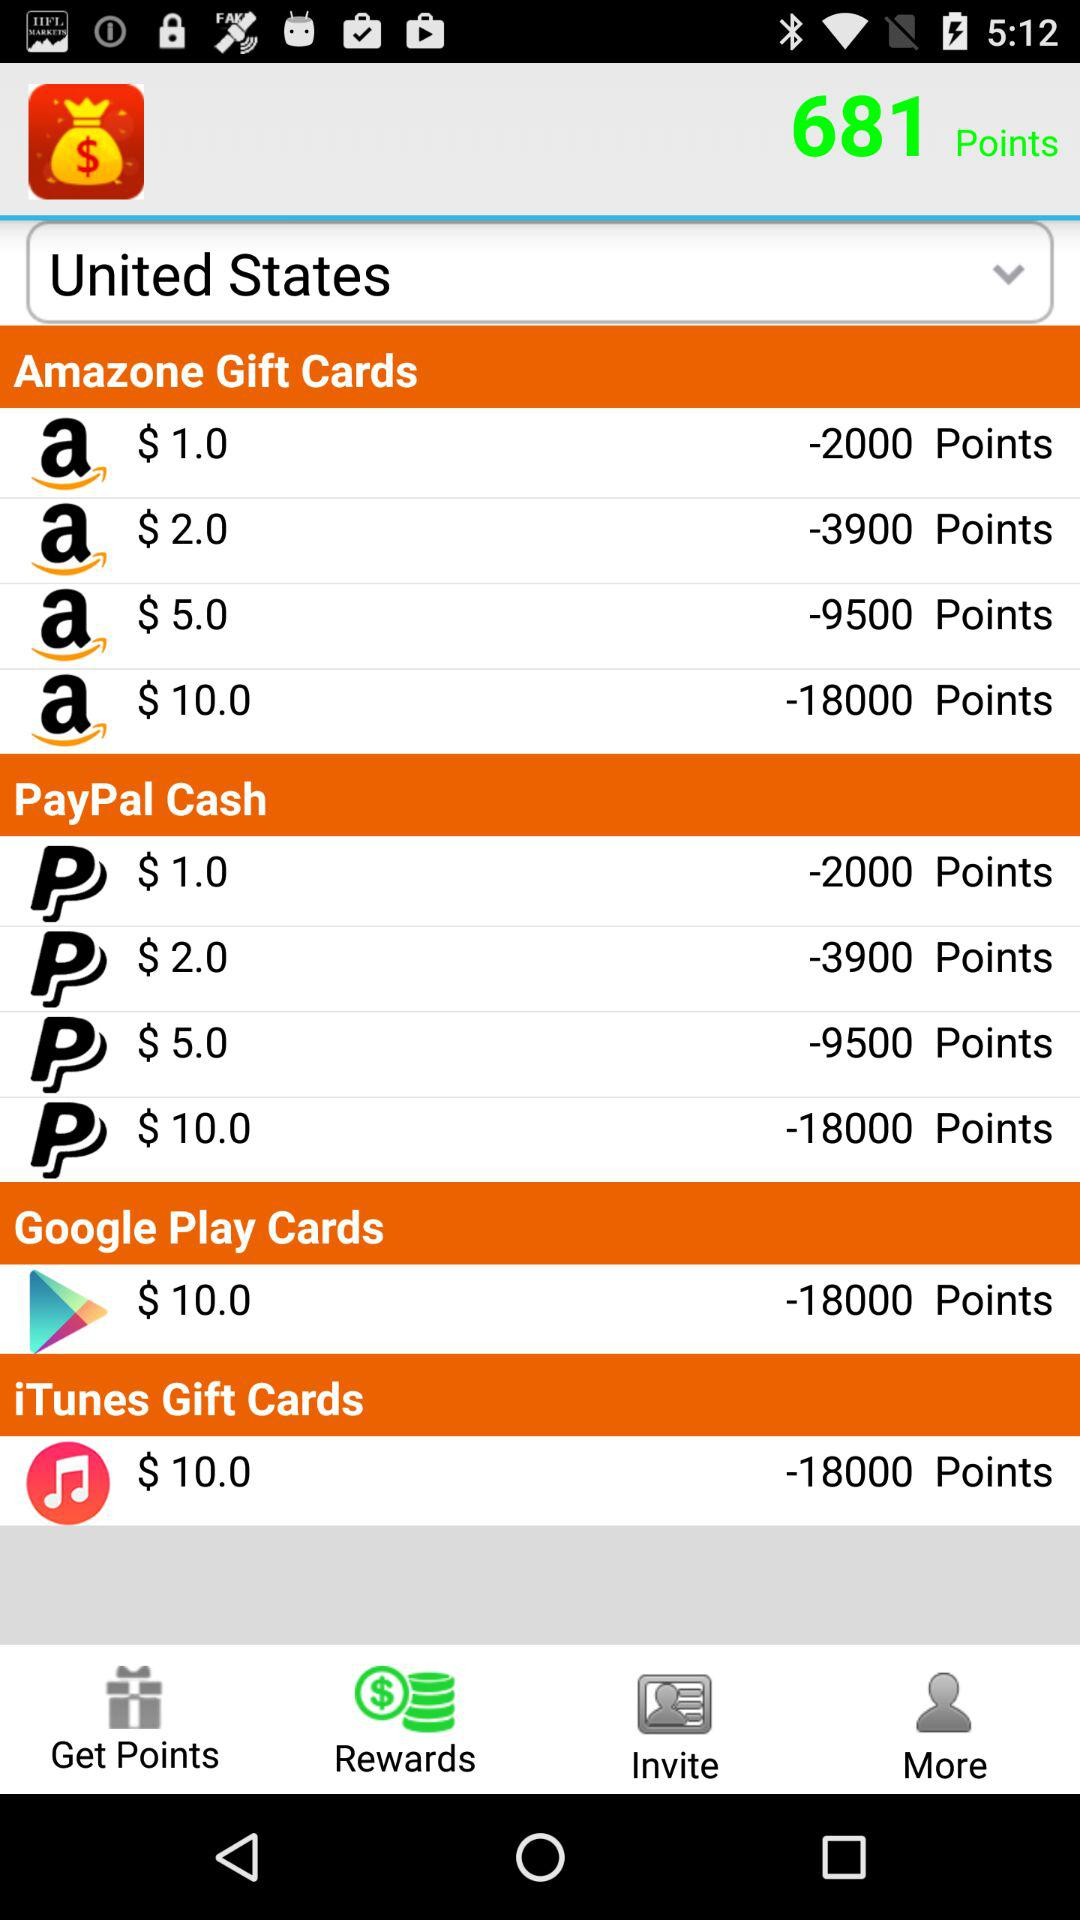How many points are there in total? There are 681 points in total. 